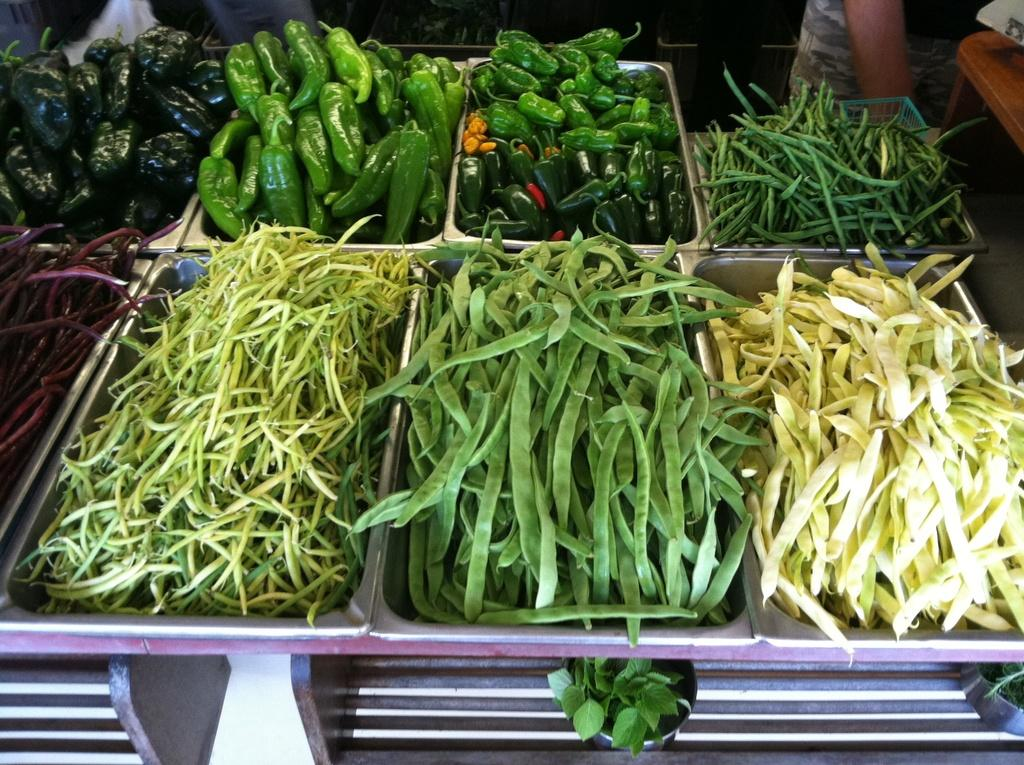What type of food can be seen in the center of the image? There are raw vegetables in the center of the image. What type of seating is located on the right side of the image? There is a bench on the right side of the image. Whose legs are visible at the top of the image? The legs of persons are visible at the top of the image. What type of flight can be seen in the image? There is no flight visible in the image. Can you describe the robin's nest in the image? There is no robin or nest present in the image. 